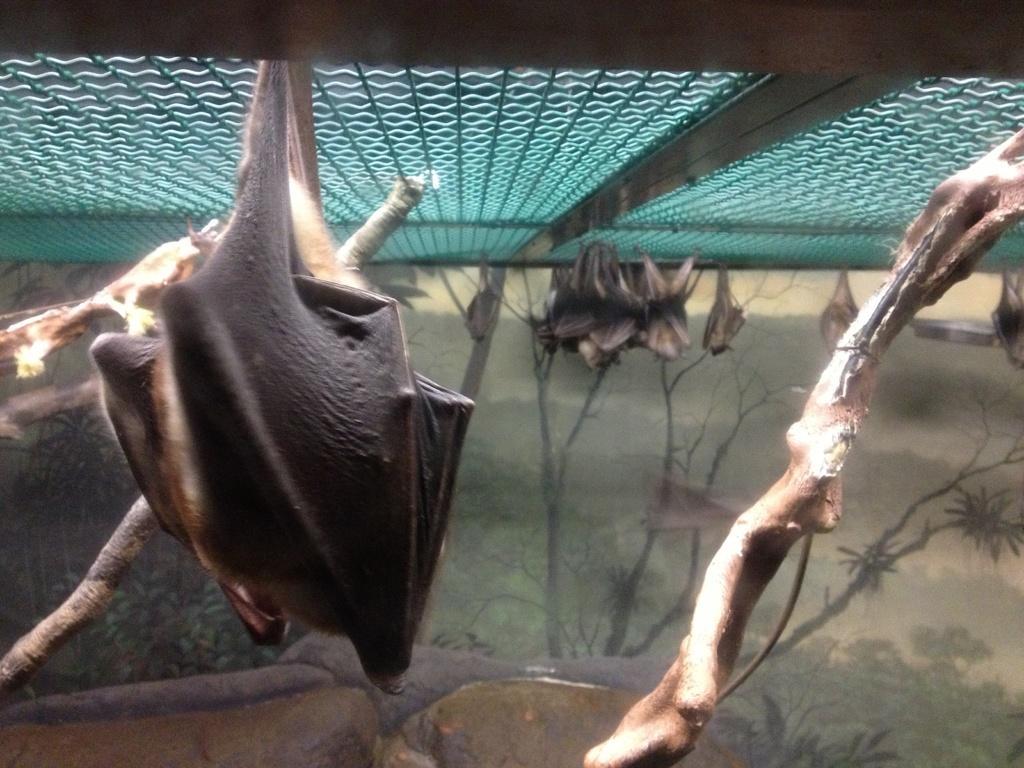Can you describe this image briefly? In this picture it looks like some bats hanging under an iron gate. In the background, we can see sketches of trees and grass. 